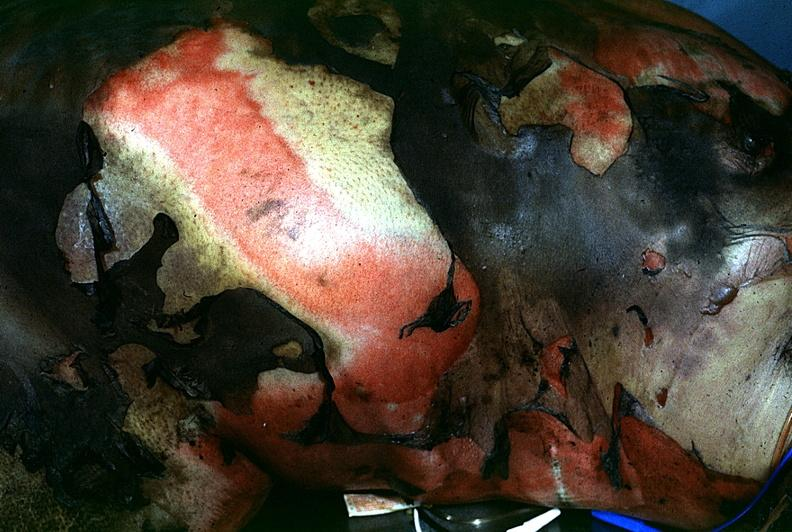do thermal burn?
Answer the question using a single word or phrase. Yes 